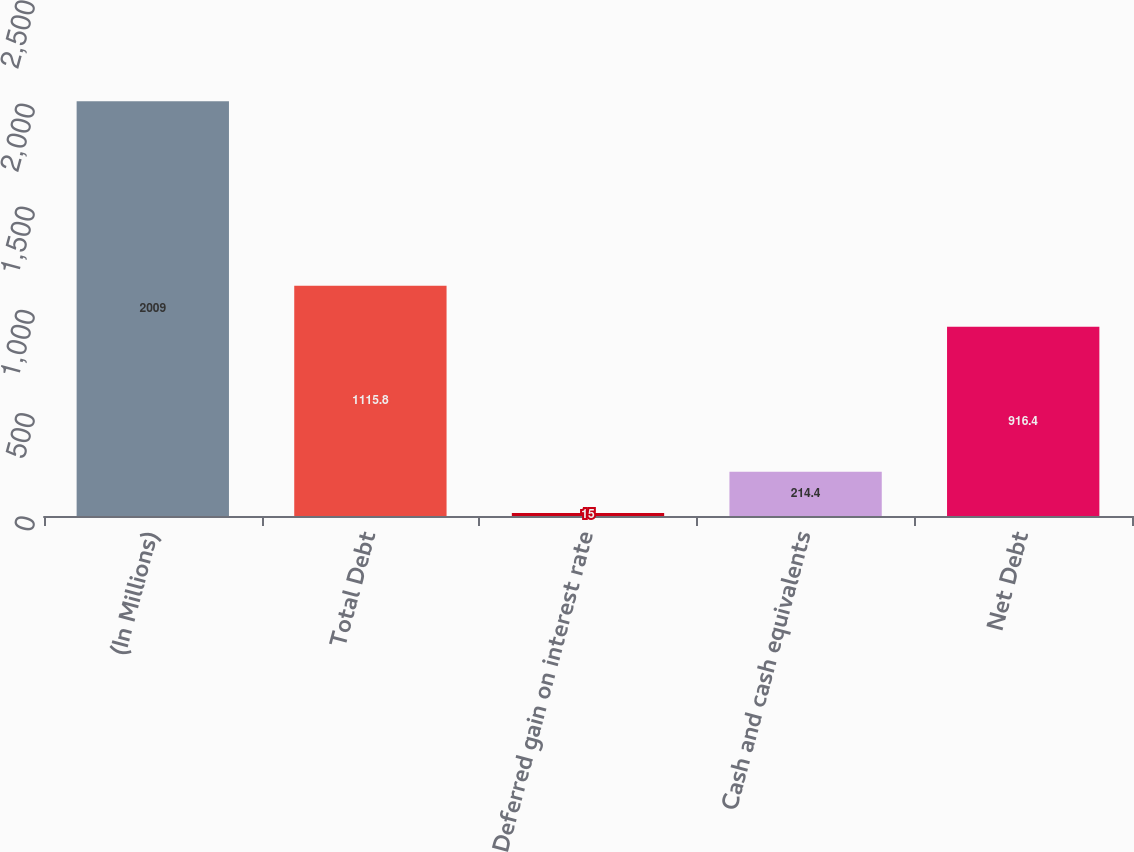Convert chart. <chart><loc_0><loc_0><loc_500><loc_500><bar_chart><fcel>(In Millions)<fcel>Total Debt<fcel>Deferred gain on interest rate<fcel>Cash and cash equivalents<fcel>Net Debt<nl><fcel>2009<fcel>1115.8<fcel>15<fcel>214.4<fcel>916.4<nl></chart> 